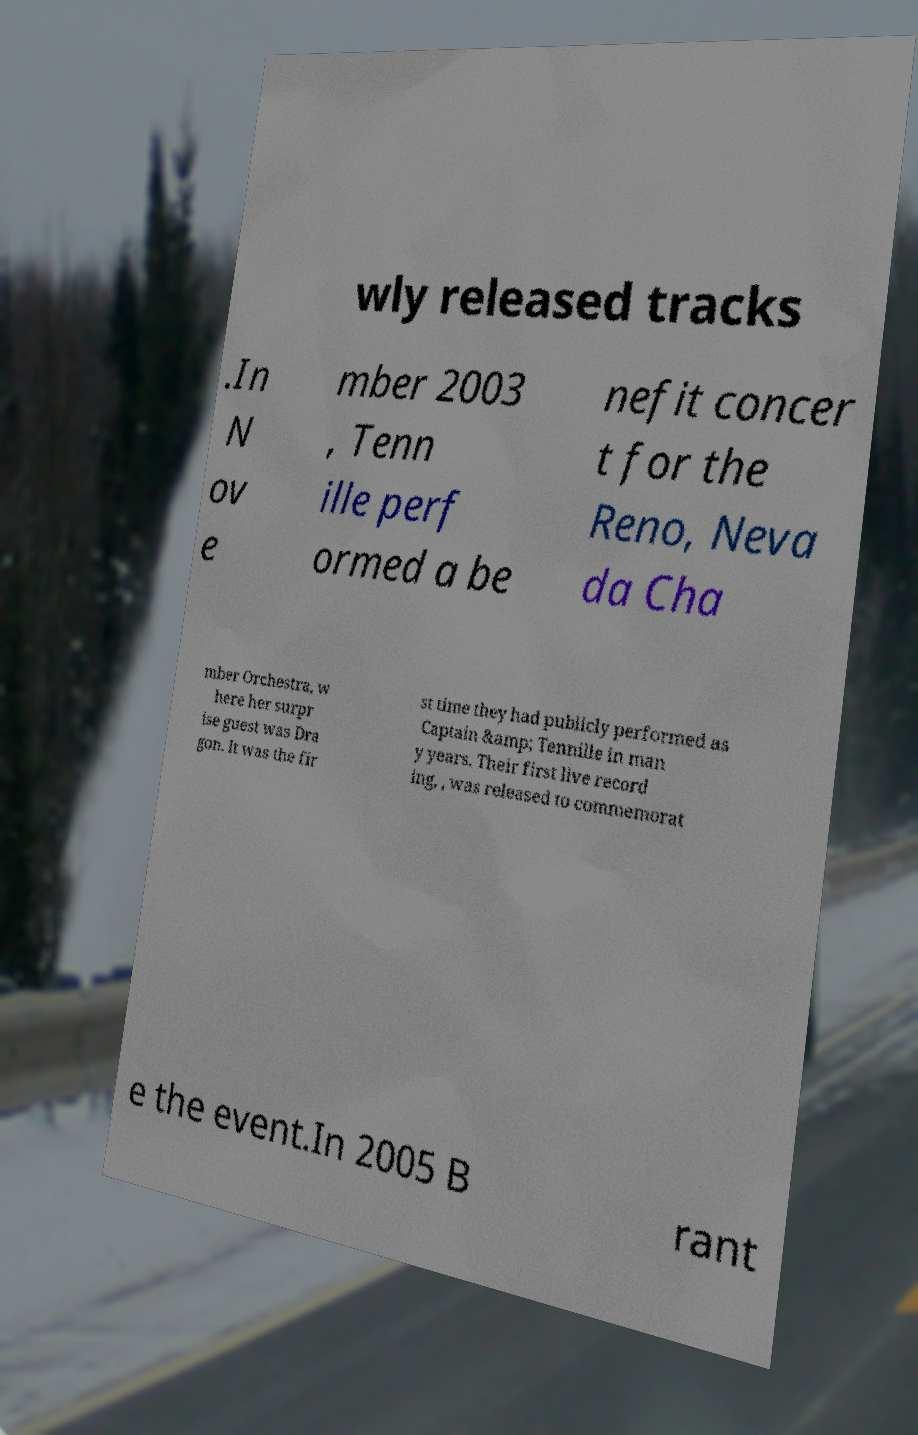I need the written content from this picture converted into text. Can you do that? wly released tracks .In N ov e mber 2003 , Tenn ille perf ormed a be nefit concer t for the Reno, Neva da Cha mber Orchestra, w here her surpr ise guest was Dra gon. It was the fir st time they had publicly performed as Captain &amp; Tennille in man y years. Their first live record ing, , was released to commemorat e the event.In 2005 B rant 